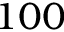Convert formula to latex. <formula><loc_0><loc_0><loc_500><loc_500>1 0 0</formula> 